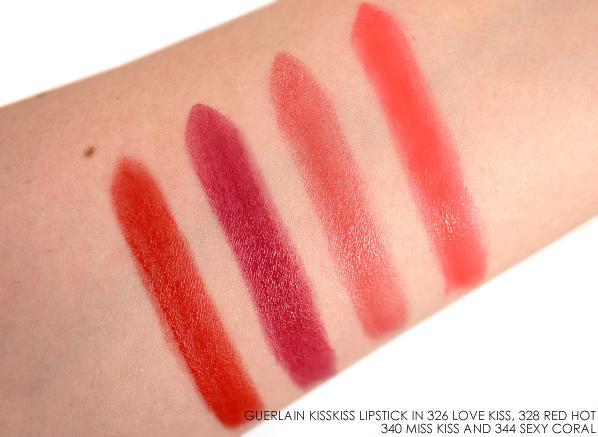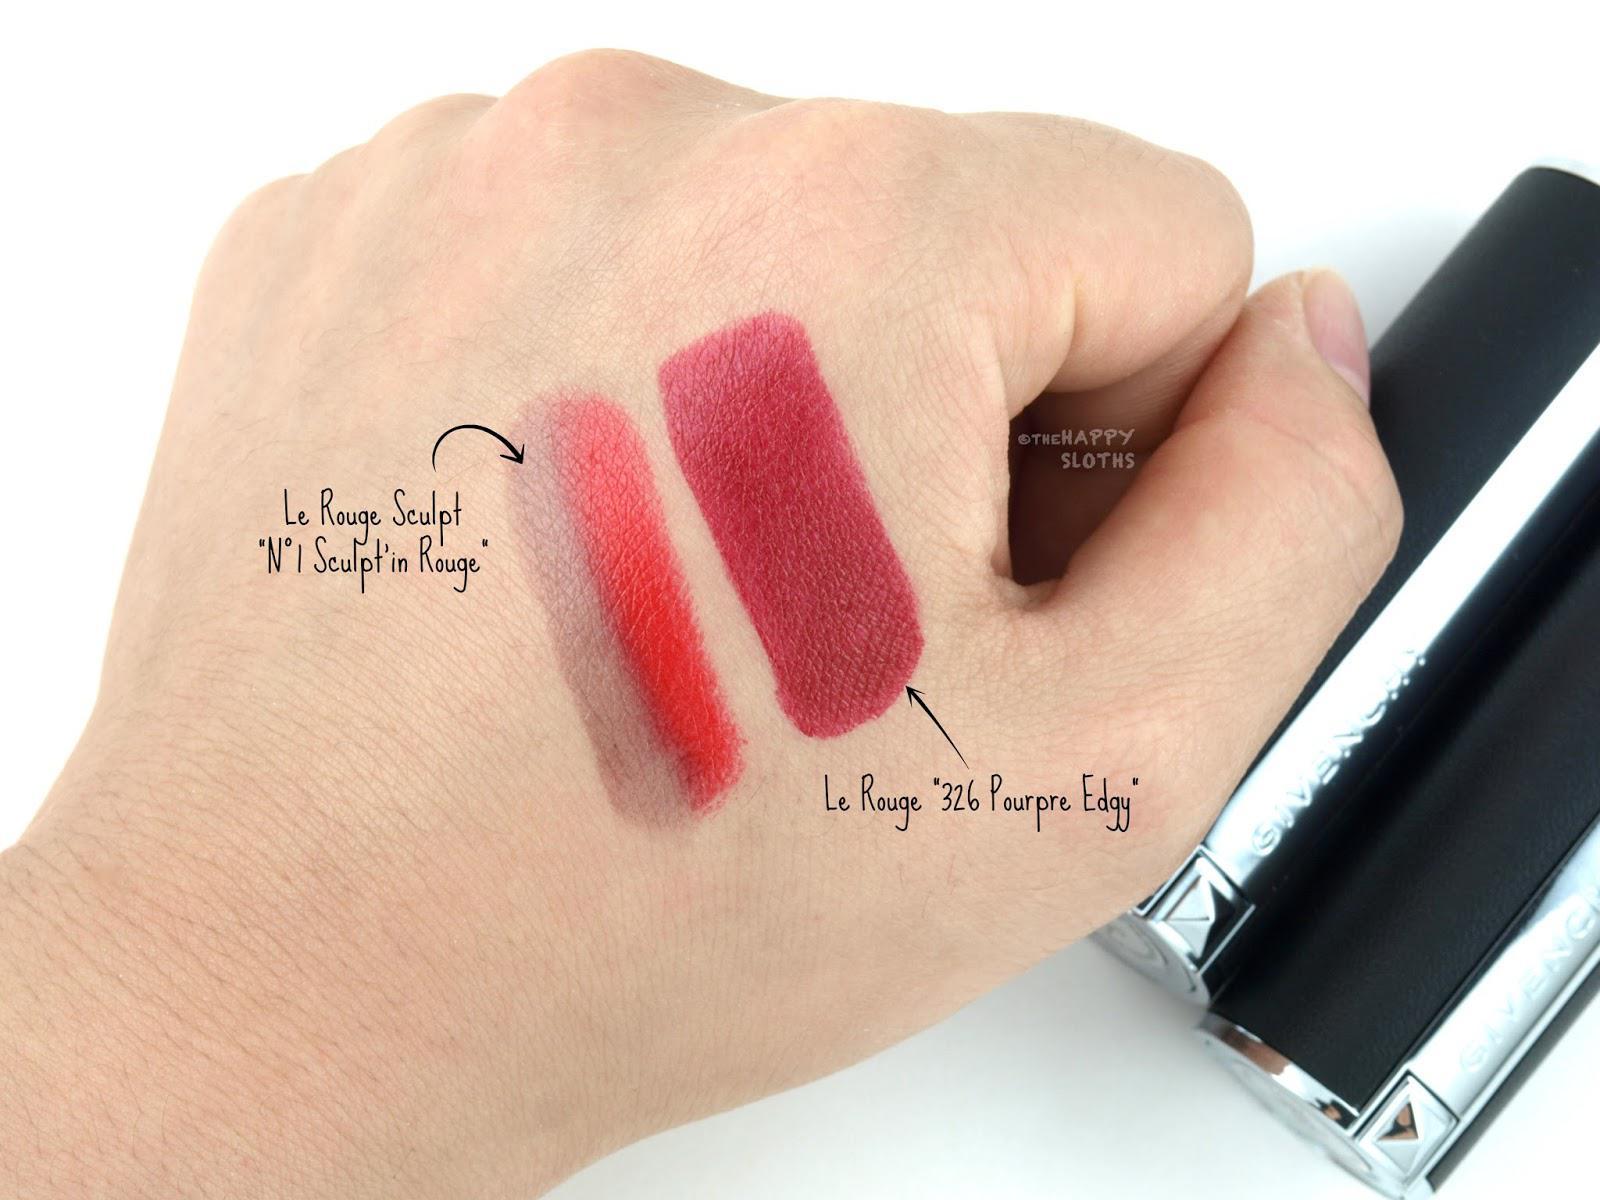The first image is the image on the left, the second image is the image on the right. Evaluate the accuracy of this statement regarding the images: "An image shows exactly two lipstick smears on a closed fist with pale skin.". Is it true? Answer yes or no. Yes. 